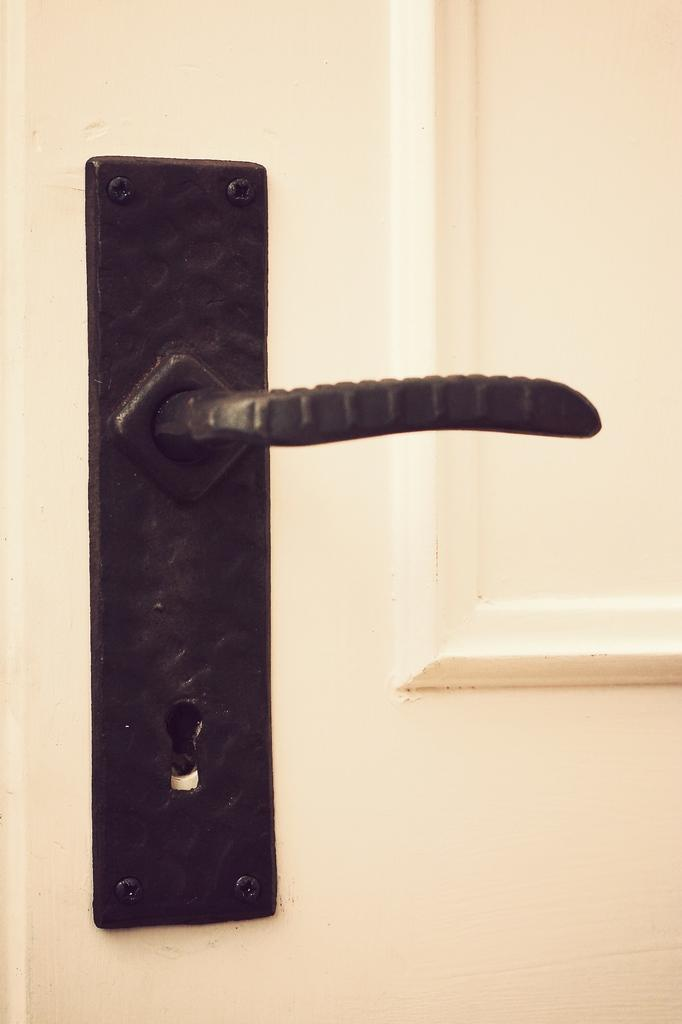What object in the image has a handle? There is a handle on a door in the image. What type of creature can be seen in the zoo in the image? There is no zoo or creature present in the image; it only features a door with a handle. 